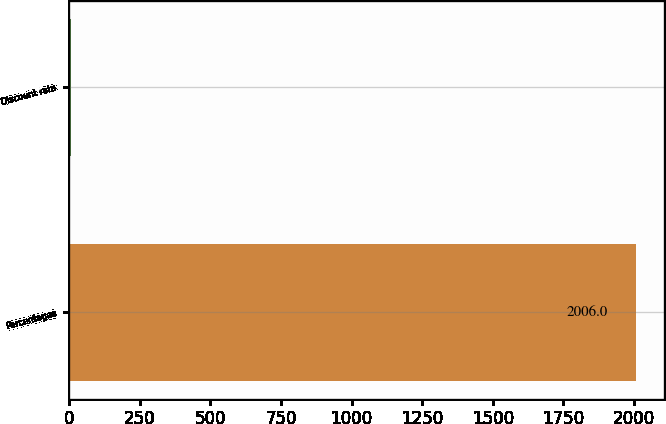<chart> <loc_0><loc_0><loc_500><loc_500><bar_chart><fcel>Percentages<fcel>Discount rate<nl><fcel>2006<fcel>5.75<nl></chart> 